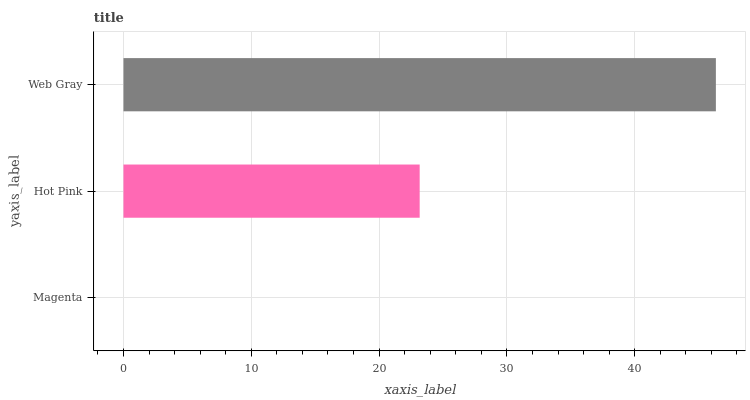Is Magenta the minimum?
Answer yes or no. Yes. Is Web Gray the maximum?
Answer yes or no. Yes. Is Hot Pink the minimum?
Answer yes or no. No. Is Hot Pink the maximum?
Answer yes or no. No. Is Hot Pink greater than Magenta?
Answer yes or no. Yes. Is Magenta less than Hot Pink?
Answer yes or no. Yes. Is Magenta greater than Hot Pink?
Answer yes or no. No. Is Hot Pink less than Magenta?
Answer yes or no. No. Is Hot Pink the high median?
Answer yes or no. Yes. Is Hot Pink the low median?
Answer yes or no. Yes. Is Web Gray the high median?
Answer yes or no. No. Is Magenta the low median?
Answer yes or no. No. 